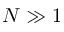<formula> <loc_0><loc_0><loc_500><loc_500>N \gg 1</formula> 